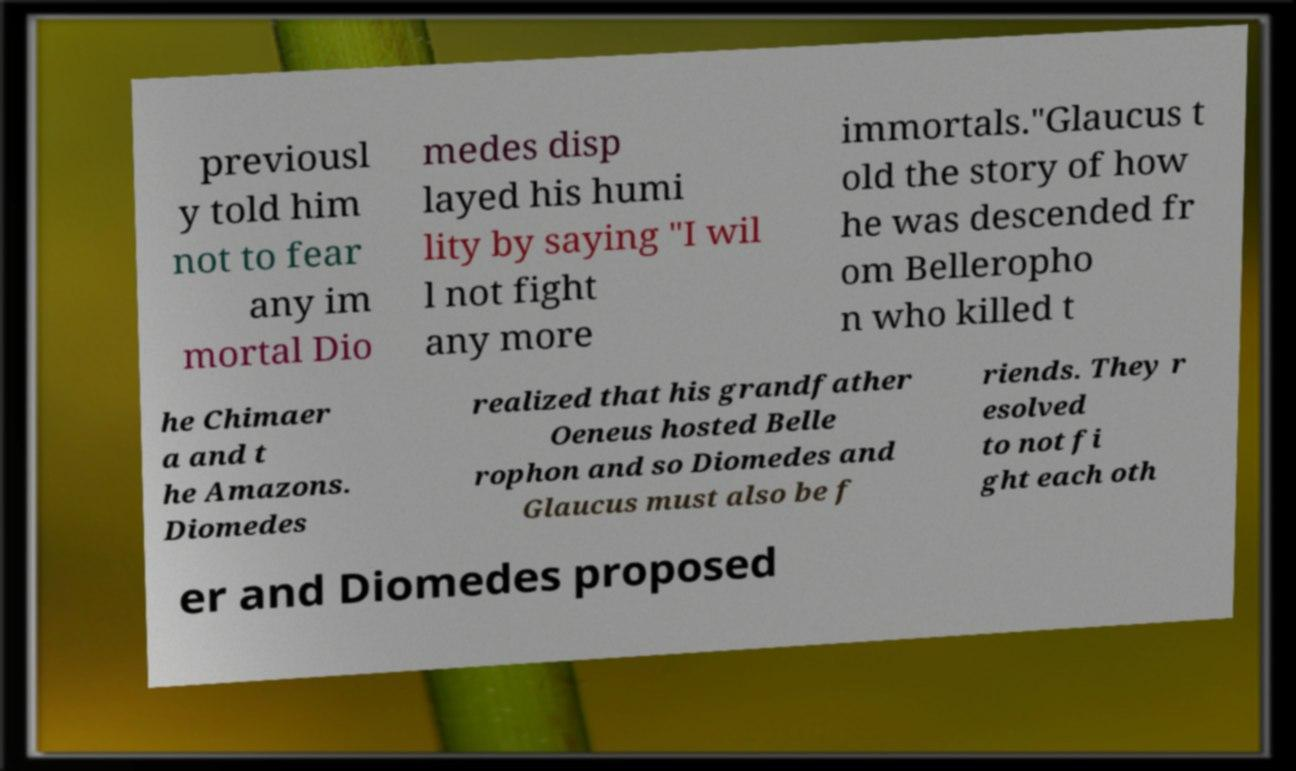I need the written content from this picture converted into text. Can you do that? previousl y told him not to fear any im mortal Dio medes disp layed his humi lity by saying "I wil l not fight any more immortals."Glaucus t old the story of how he was descended fr om Belleropho n who killed t he Chimaer a and t he Amazons. Diomedes realized that his grandfather Oeneus hosted Belle rophon and so Diomedes and Glaucus must also be f riends. They r esolved to not fi ght each oth er and Diomedes proposed 